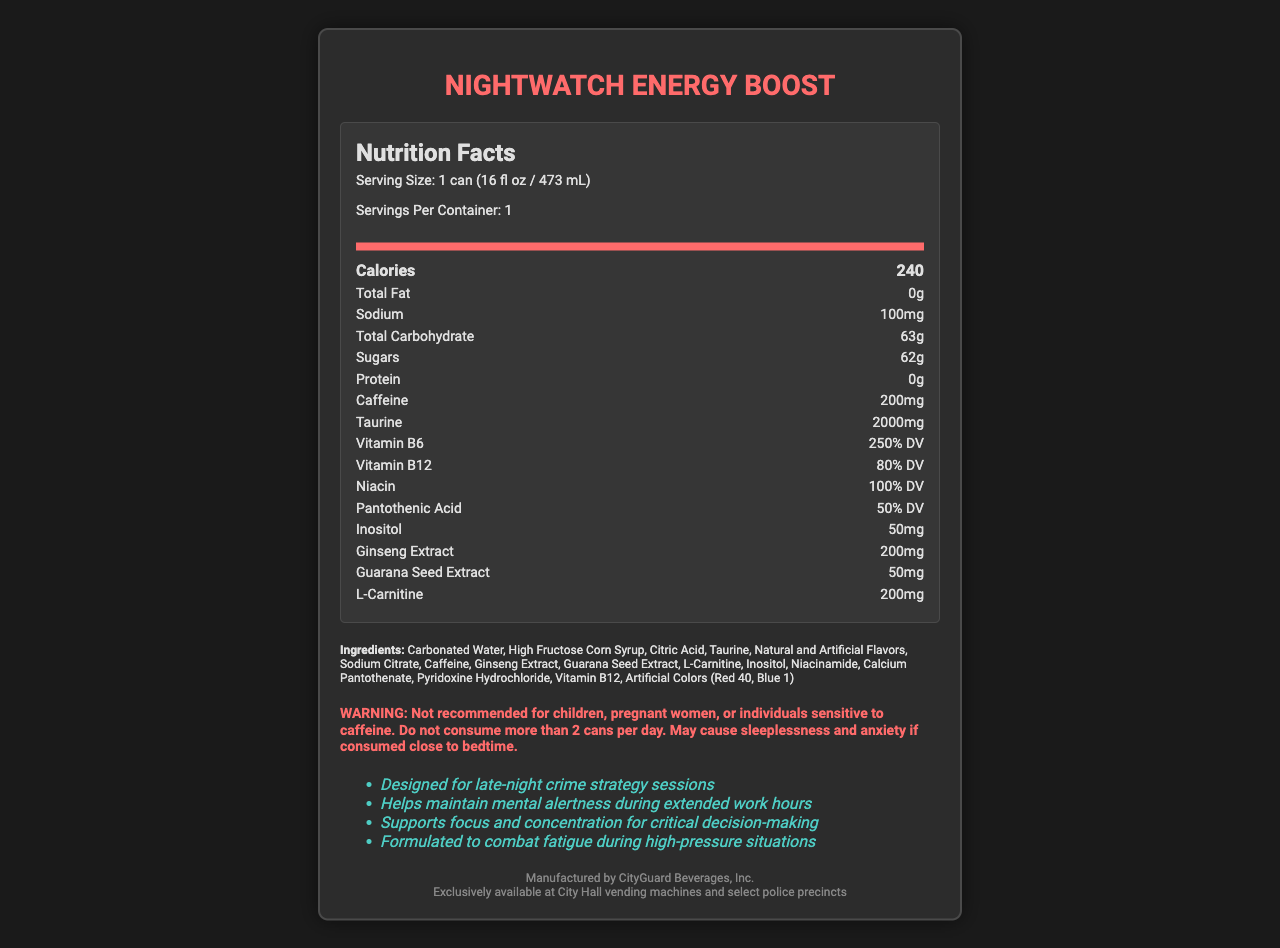what is the serving size of NightWatch Energy Boost? The serving size is explicitly mentioned in the document as "1 can (16 fl oz / 473 mL)".
Answer: 1 can (16 fl oz / 473 mL) how much sodium is in one serving? The sodium content is listed as 100mg.
Answer: 100mg what is the main ingredient in NightWatch Energy Boost? The first ingredient listed is Carbonated Water, indicating it is the main ingredient by volume.
Answer: Carbonated Water how many calories are in one can? The calories per serving are clearly listed as 240.
Answer: 240 how many grams of sugars are in one serving? The sugars content is listed as 62g.
Answer: 62g how much caffeine does one can contain? The caffeine content is provided as 200mg.
Answer: 200mg how many vitamins are listed and what are their daily values? A. 2 vitamins B. 3 vitamins C. 4 vitamins D. 5 vitamins The document lists Vitamin B6 (250% DV), Vitamin B12 (80% DV), Niacin (100% DV), and Pantothenic Acid (50% DV), making it a total of four vitamins.
Answer: C. 4 vitamins what is the recommended daily limit for the consumption of NightWatch Energy Boost? The warning section states to not consume more than 2 cans per day.
Answer: 2 cans per day which artificial colors are used in the product? A. Red 40 and Blue 1 B. Yellow 5 and Red 40 C. Blue 1 and Yellow 5 D. Red 3 and Blue 2 The ingredients list specifically mentions "Artificial Colors (Red 40, Blue 1)".
Answer: A. Red 40 and Blue 1 is NightWatch Energy Boost suitable for children? The warning clearly states that it is not recommended for children.
Answer: No summarize the key features and ingredients of NightWatch Energy Boost. This summary covers the main aspects of the document, including nutritional content, key ingredients, warnings, and marketing claims.
Answer: NightWatch Energy Boost is an energy drink with a serving size of 1 can (16 fl oz / 473 mL), providing 240 calories per serving. Key ingredients include Carbonated Water, High Fructose Corn Syrup, Taurine, Caffeine, and various vitamins and extracts. It contains 200mg of caffeine and is not recommended for children, pregnant women, or caffeine-sensitive individuals. It is marketed to help maintain mental alertness and focus during late-night sessions. how many grams of total carbohydrates are in one serving? The document states that there are 63g of total carbohydrates per serving.
Answer: 63g what are three benefits of consuming NightWatch Energy Boost as stated in the marketing claims? The marketing claims section lists these benefits explicitly.
Answer: Helps maintain mental alertness during extended work hours, Supports focus and concentration for critical decision-making, Formulated to combat fatigue during high-pressure situations where can NightWatch Energy Boost be purchased? The distribution section mentions these specific locations.
Answer: Exclusively available at City Hall vending machines and select police precincts how much taurine is in one serving? The taurine content is listed as 2000mg per can.
Answer: 2000mg what is the address of CityGuard Beverages, Inc.? The document does not provide the address of the manufacturer, CityGuard Beverages, Inc.
Answer: Cannot be determined 